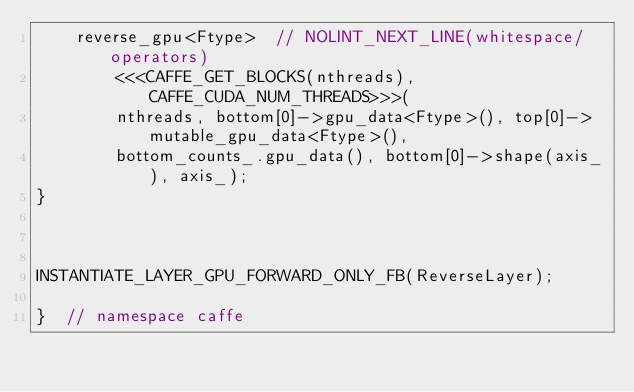Convert code to text. <code><loc_0><loc_0><loc_500><loc_500><_Cuda_>	reverse_gpu<Ftype>  // NOLINT_NEXT_LINE(whitespace/operators)
        <<<CAFFE_GET_BLOCKS(nthreads), CAFFE_CUDA_NUM_THREADS>>>(
        nthreads, bottom[0]->gpu_data<Ftype>(), top[0]->mutable_gpu_data<Ftype>(), 
        bottom_counts_.gpu_data(), bottom[0]->shape(axis_), axis_);
}



INSTANTIATE_LAYER_GPU_FORWARD_ONLY_FB(ReverseLayer);

}  // namespace caffe
</code> 